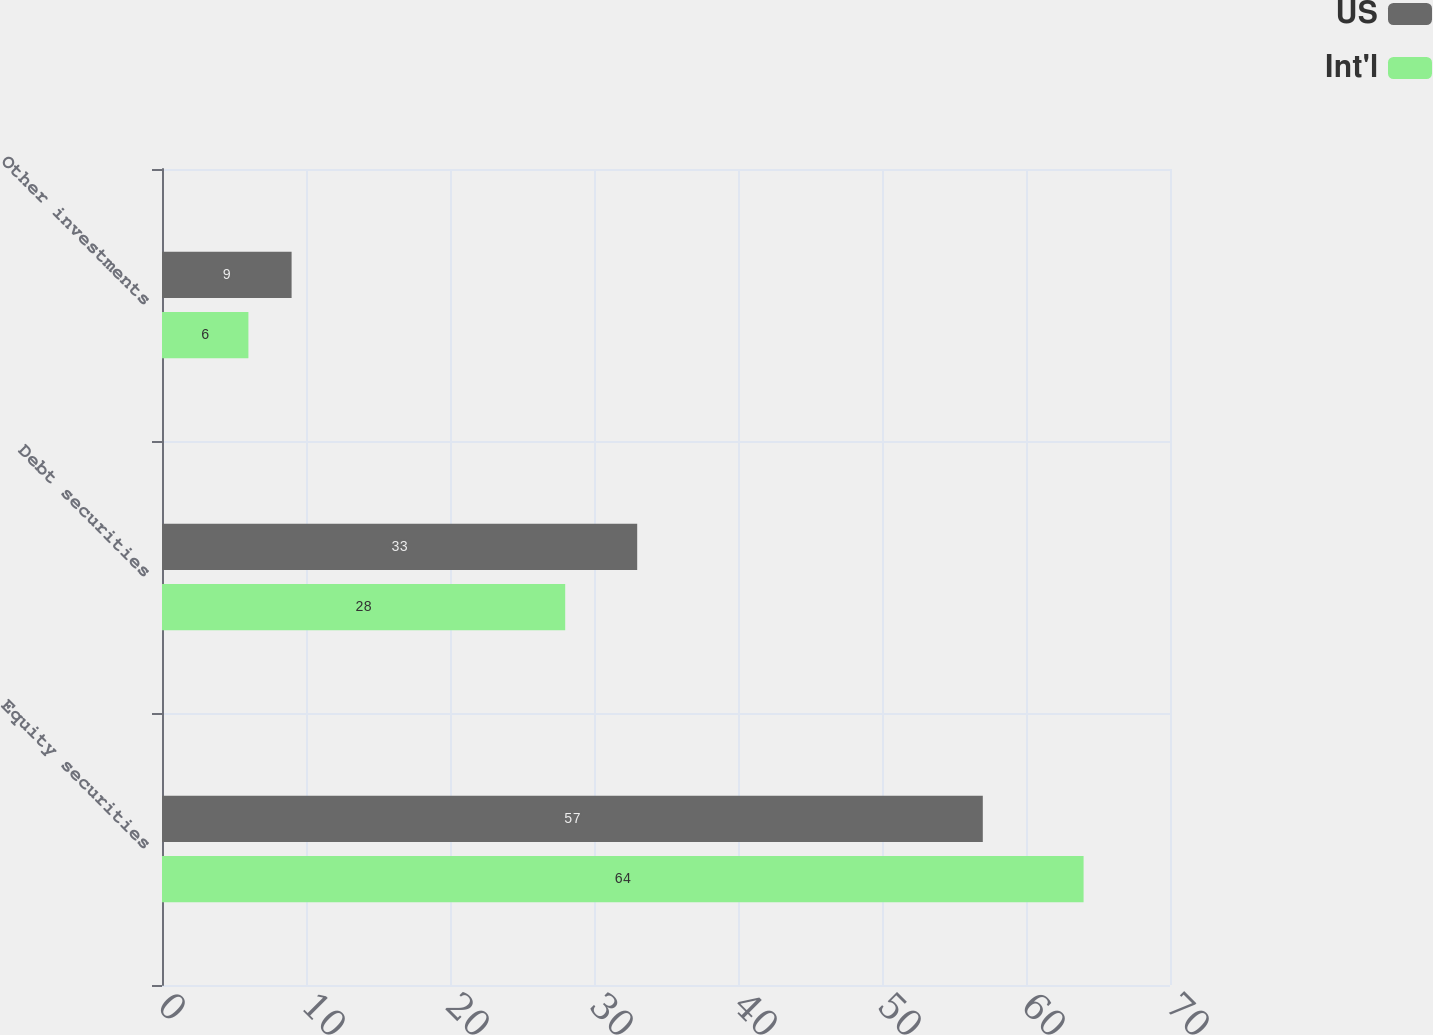Convert chart. <chart><loc_0><loc_0><loc_500><loc_500><stacked_bar_chart><ecel><fcel>Equity securities<fcel>Debt securities<fcel>Other investments<nl><fcel>US<fcel>57<fcel>33<fcel>9<nl><fcel>Int'l<fcel>64<fcel>28<fcel>6<nl></chart> 